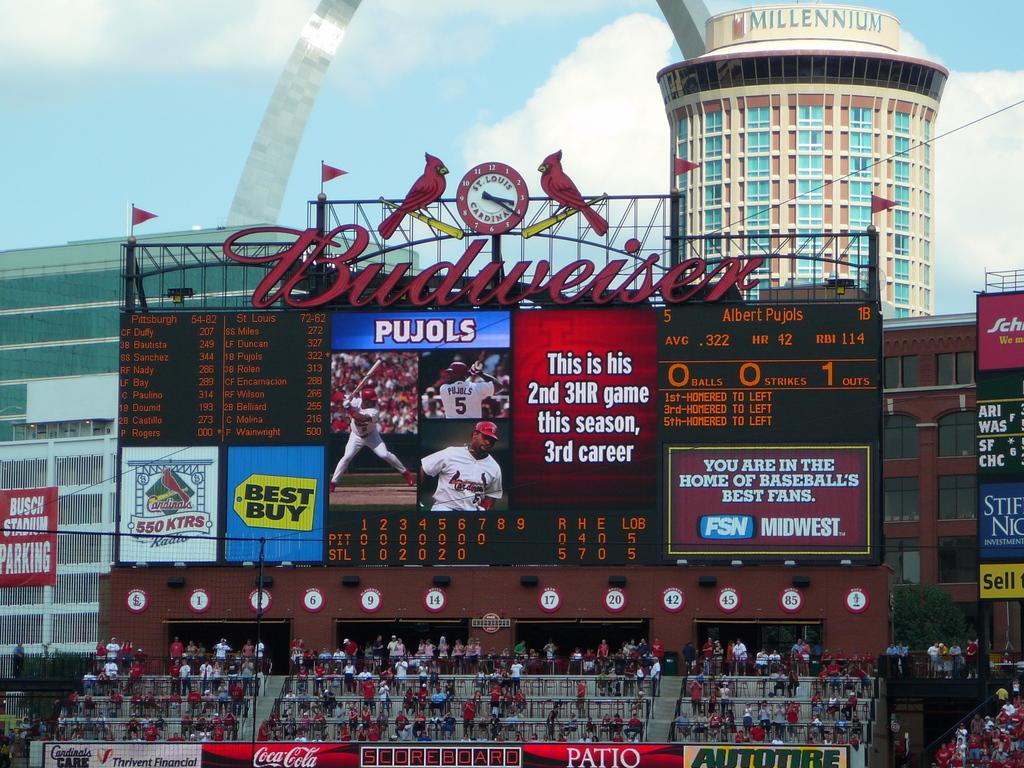How many outs has the player had?
Provide a succinct answer. 1. 